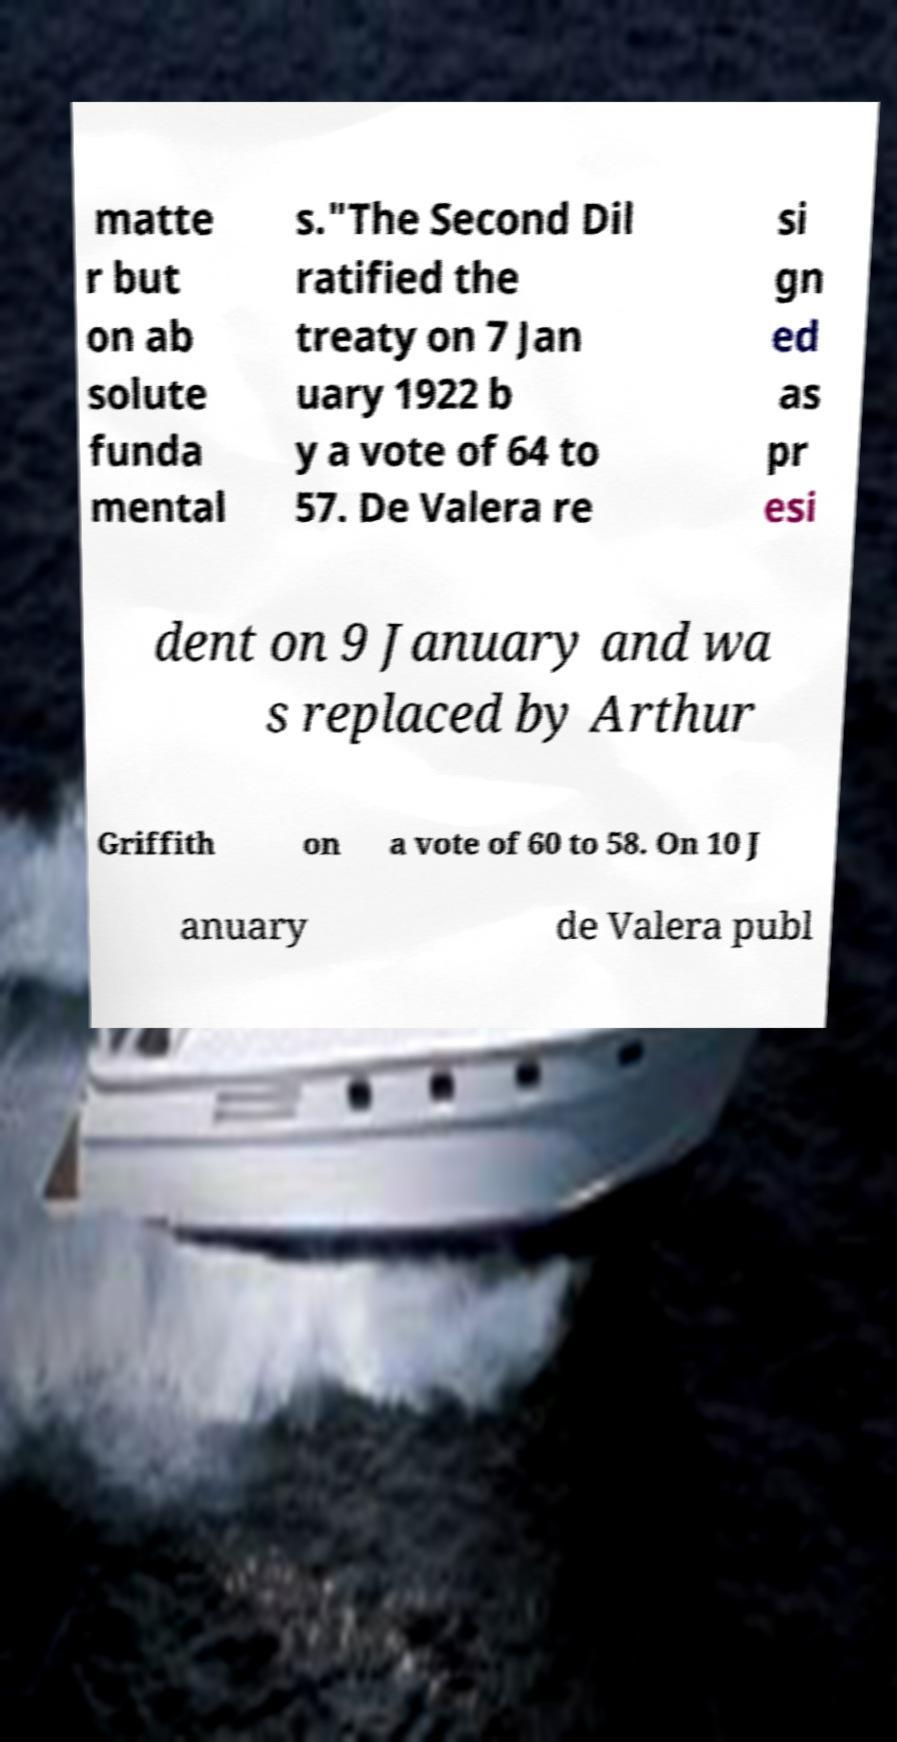For documentation purposes, I need the text within this image transcribed. Could you provide that? matte r but on ab solute funda mental s."The Second Dil ratified the treaty on 7 Jan uary 1922 b y a vote of 64 to 57. De Valera re si gn ed as pr esi dent on 9 January and wa s replaced by Arthur Griffith on a vote of 60 to 58. On 10 J anuary de Valera publ 